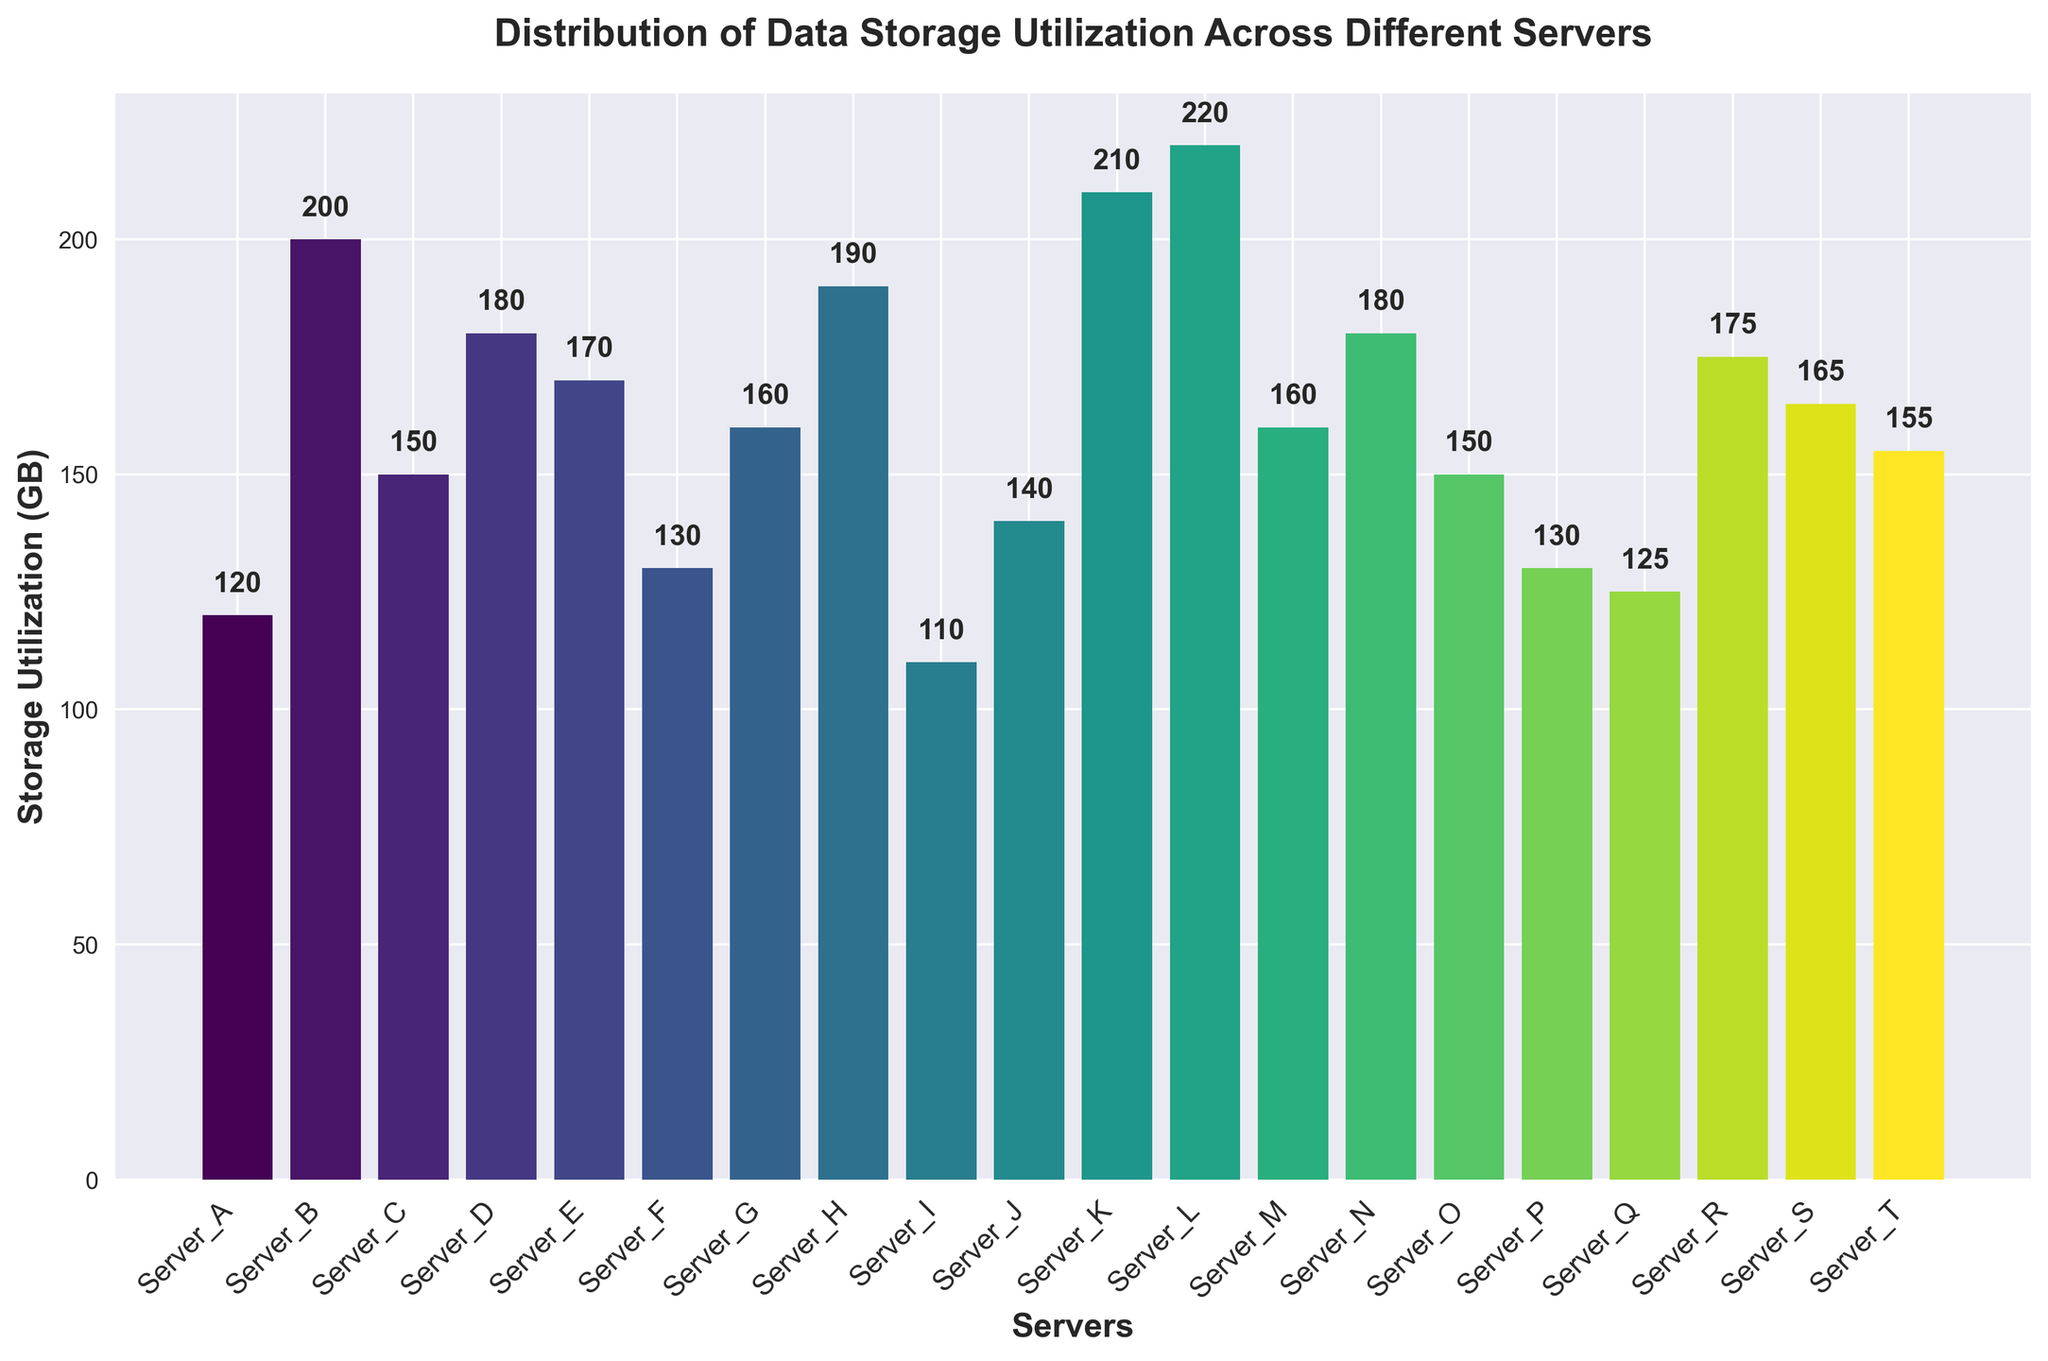Which server has the highest storage utilization? By visually examining the bar chart, we can identify the tallest bar. The tallest bar corresponds to Server_L, which has the highest storage utilization.
Answer: Server_L Which server has the lowest storage utilization? By looking at the shortest bar in the chart, we can determine that Server_I has the lowest storage utilization.
Answer: Server_I What is the difference in storage utilization between Server_L and Server_A? Server_L has 220 GB of storage utilization, and Server_A has 120 GB. The difference is calculated as 220 - 120 = 100 GB.
Answer: 100 GB What is the average storage utilization across all servers? Sum all the storage utilizations and divide by the number of servers. The total storage utilization is 2985 GB, and there are 20 servers, so the average is 2985 / 20 = 149.25 GB.
Answer: 149.25 GB Which servers have storage utilization greater than 180 GB? By examining the bars that exceed 180 GB, we identify Servers B, H, K, and L.
Answer: Server_B, Server_H, Server_K, Server_L What is the combined storage utilization of Server_A, Server_B, and Server_C? Add the storage utilizations of Server_A (120 GB), Server_B (200 GB), and Server_C (150 GB), which gives 120 + 200 + 150 = 470 GB.
Answer: 470 GB Which server has a storage utilization closest to the average? The average storage utilization is 149.25 GB. Server_C has a utilization of 150 GB, which is the closest to the average.
Answer: Server_C How many servers have storage utilization between 150 GB and 200 GB? By counting the number of bars within the range of 150 GB to 200 GB inclusive, we find Server_C, Server_D, Server_E, Server_G, Server_H, Server_M, Server_N, Server_O, Server_R, Server_S, and Server_T, making a total of 11 servers.
Answer: 11 servers Is there a visible pattern in storage utilization among the servers? Examining the bar heights, there is a broad range in storage utilization from 110 GB to 220 GB with no clear trend or clustering, indicating a relatively even distribution across different servers.
Answer: No clear pattern What is the total storage utilized by servers with less than 130 GB? Servers with less than 130 GB are Server_I (110 GB) and Server_Q (125 GB). Their combined utilization is 110 + 125 = 235 GB.
Answer: 235 GB 